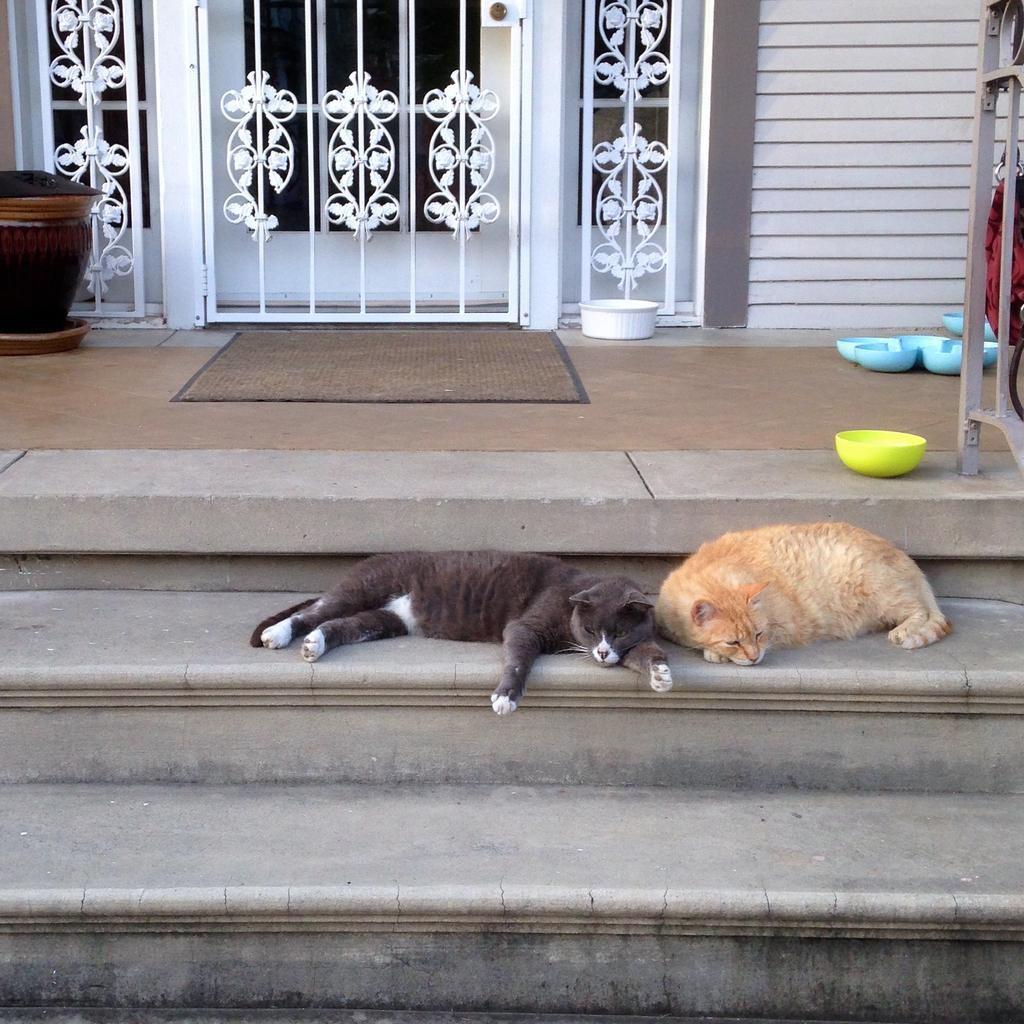Please provide a concise description of this image. Here in this picture we can see a couple of cats laying on the steps and behind that we can see a floor mat an some bowls present on the floor and we can also see a door present and on the left side we can see a plant pot present. 